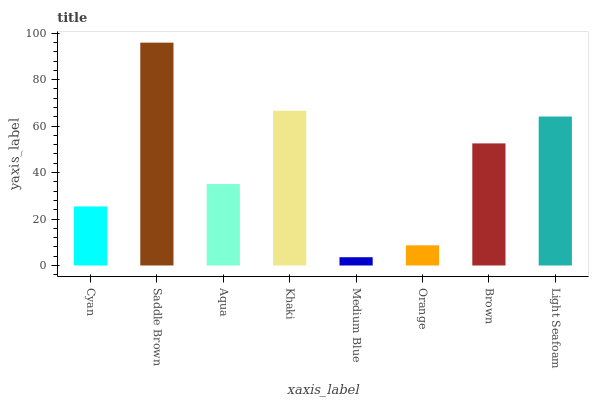Is Medium Blue the minimum?
Answer yes or no. Yes. Is Saddle Brown the maximum?
Answer yes or no. Yes. Is Aqua the minimum?
Answer yes or no. No. Is Aqua the maximum?
Answer yes or no. No. Is Saddle Brown greater than Aqua?
Answer yes or no. Yes. Is Aqua less than Saddle Brown?
Answer yes or no. Yes. Is Aqua greater than Saddle Brown?
Answer yes or no. No. Is Saddle Brown less than Aqua?
Answer yes or no. No. Is Brown the high median?
Answer yes or no. Yes. Is Aqua the low median?
Answer yes or no. Yes. Is Aqua the high median?
Answer yes or no. No. Is Medium Blue the low median?
Answer yes or no. No. 